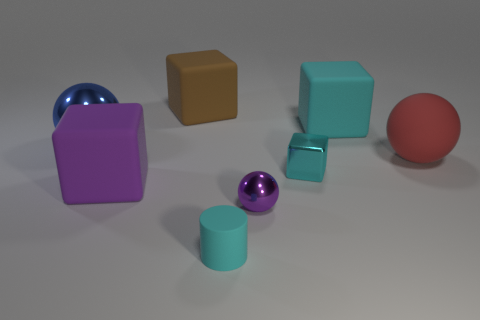Subtract all blue metal spheres. How many spheres are left? 2 Subtract all blue cylinders. How many cyan cubes are left? 2 Add 2 small metal cubes. How many objects exist? 10 Subtract all purple cubes. How many cubes are left? 3 Subtract all brown spheres. Subtract all gray cubes. How many spheres are left? 3 Subtract all cylinders. How many objects are left? 7 Subtract 0 green blocks. How many objects are left? 8 Subtract all small gray cubes. Subtract all big blue metallic balls. How many objects are left? 7 Add 3 purple rubber cubes. How many purple rubber cubes are left? 4 Add 6 red rubber cubes. How many red rubber cubes exist? 6 